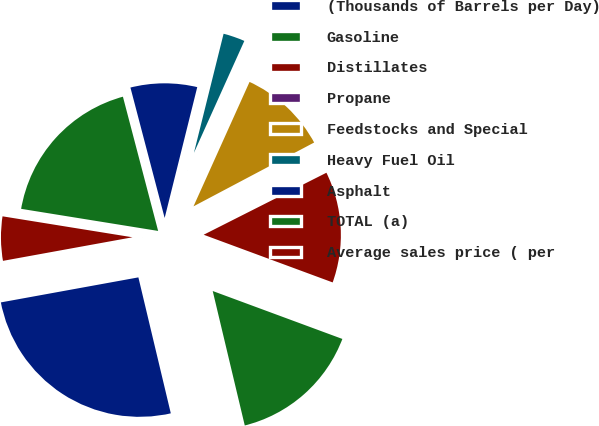Convert chart to OTSL. <chart><loc_0><loc_0><loc_500><loc_500><pie_chart><fcel>(Thousands of Barrels per Day)<fcel>Gasoline<fcel>Distillates<fcel>Propane<fcel>Feedstocks and Special<fcel>Heavy Fuel Oil<fcel>Asphalt<fcel>TOTAL (a)<fcel>Average sales price ( per<nl><fcel>25.86%<fcel>15.64%<fcel>13.08%<fcel>0.3%<fcel>10.52%<fcel>2.85%<fcel>7.97%<fcel>18.37%<fcel>5.41%<nl></chart> 